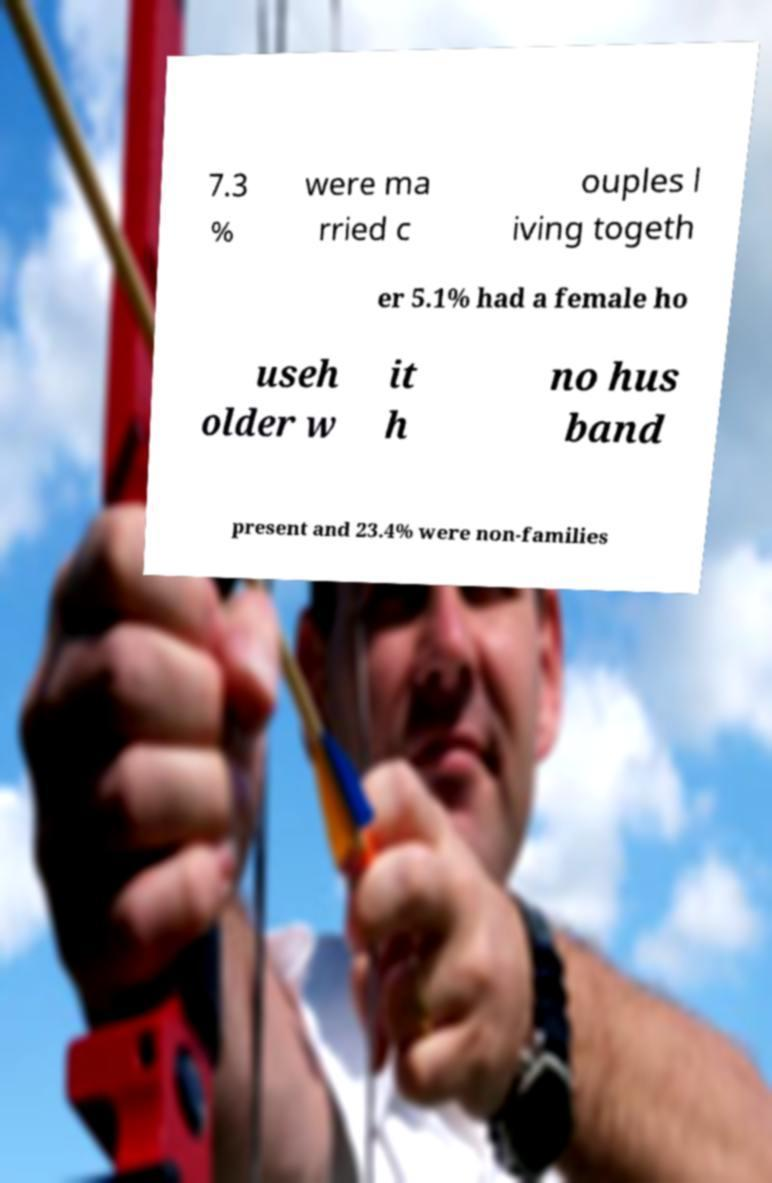Can you accurately transcribe the text from the provided image for me? 7.3 % were ma rried c ouples l iving togeth er 5.1% had a female ho useh older w it h no hus band present and 23.4% were non-families 